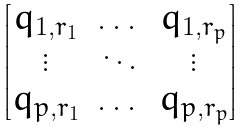<formula> <loc_0><loc_0><loc_500><loc_500>\begin{bmatrix} q _ { 1 , r _ { 1 } } & \dots & q _ { 1 , r _ { p } } \\ \vdots & \ddots & \vdots \\ q _ { p , r _ { 1 } } & \dots & q _ { p , r _ { p } } \end{bmatrix}</formula> 